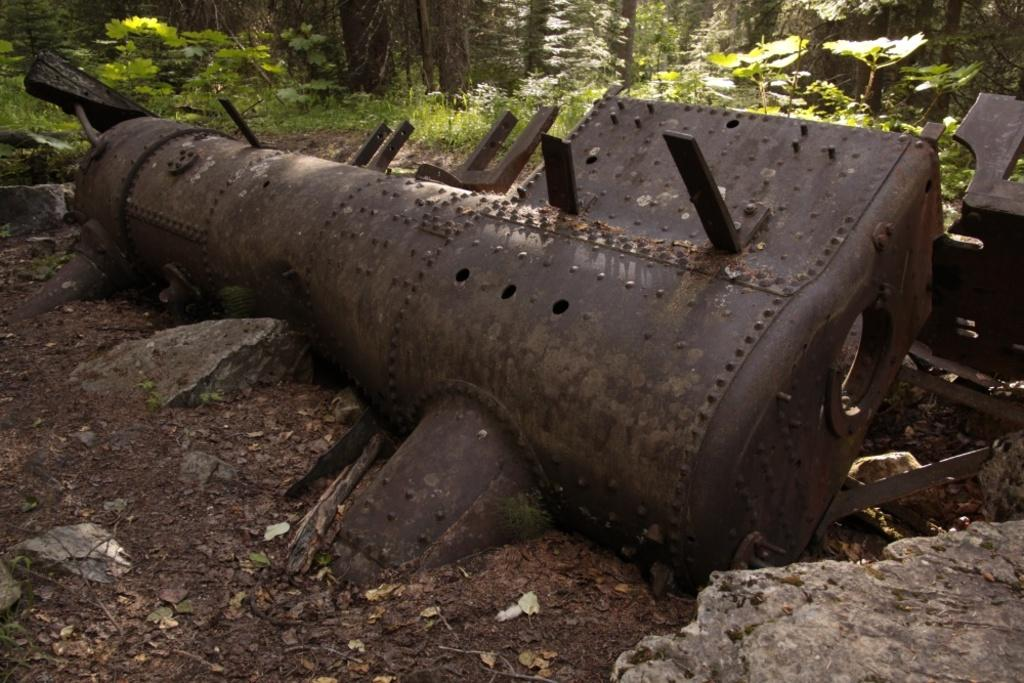What is the main object in the center of the image? There is an iron object in the center of the image. What is located at the bottom of the image? There is sand, dry leaves, and rocks visible at the bottom of the image. What can be seen in the background of the image? There are plants and trees in the background of the image. What arithmetic problem is being solved by the family in the image? There is no family present in the image, nor is there any indication of an arithmetic problem being solved. 